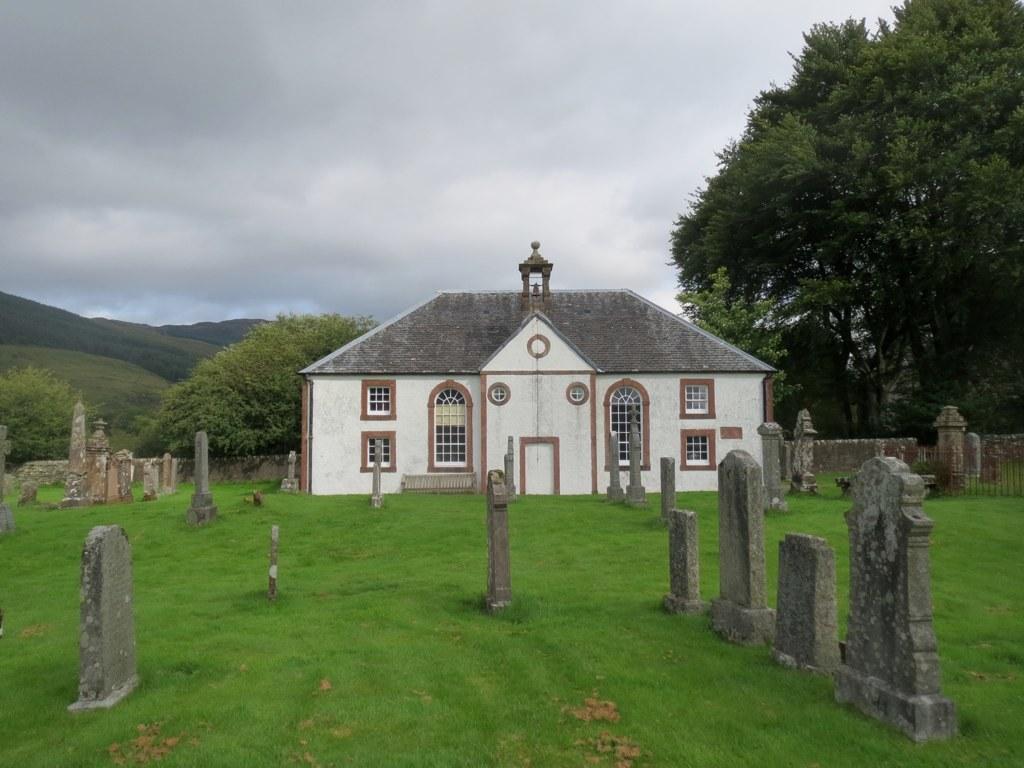Please provide a concise description of this image. In the center of the image we can see the sky, clouds, hills, trees, grass, headstones, one building, windows, compound wall and a few other objects. 